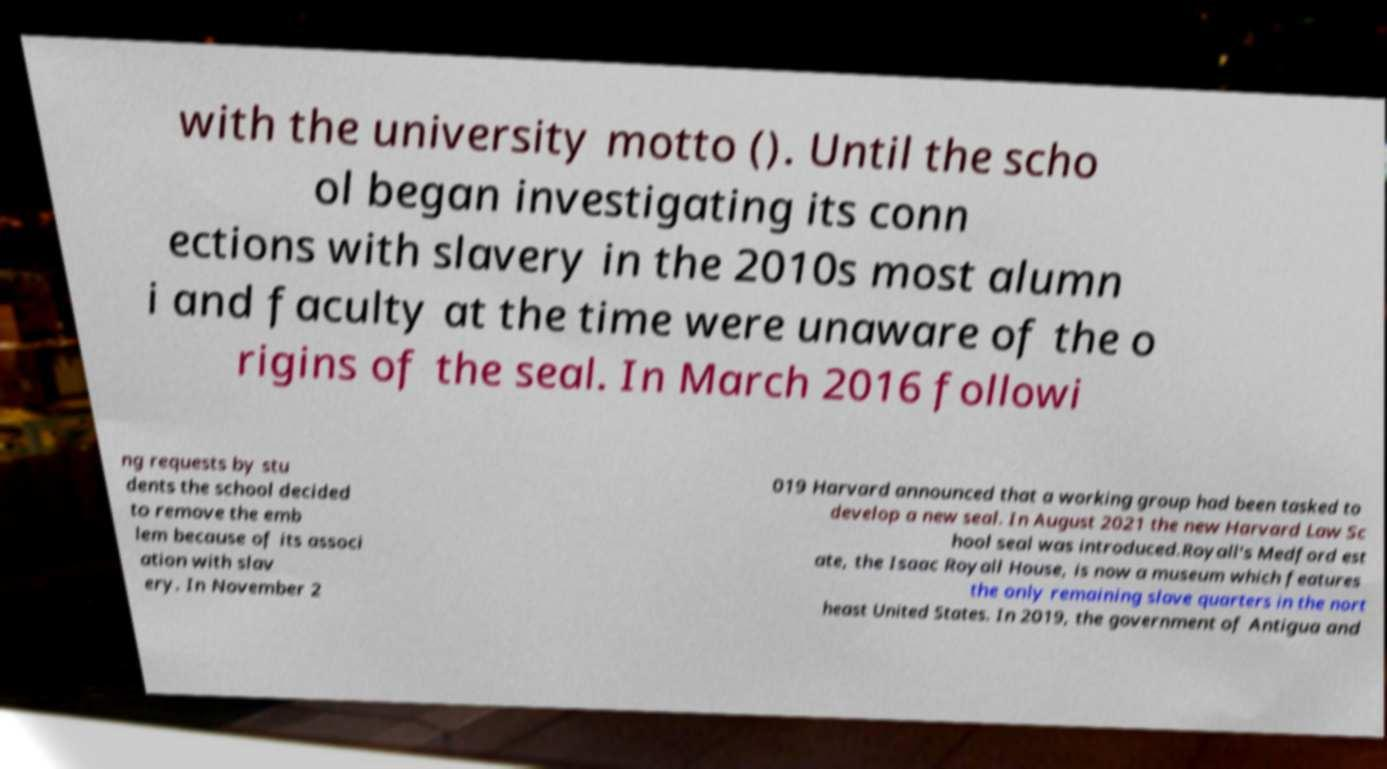I need the written content from this picture converted into text. Can you do that? with the university motto (). Until the scho ol began investigating its conn ections with slavery in the 2010s most alumn i and faculty at the time were unaware of the o rigins of the seal. In March 2016 followi ng requests by stu dents the school decided to remove the emb lem because of its associ ation with slav ery. In November 2 019 Harvard announced that a working group had been tasked to develop a new seal. In August 2021 the new Harvard Law Sc hool seal was introduced.Royall's Medford est ate, the Isaac Royall House, is now a museum which features the only remaining slave quarters in the nort heast United States. In 2019, the government of Antigua and 